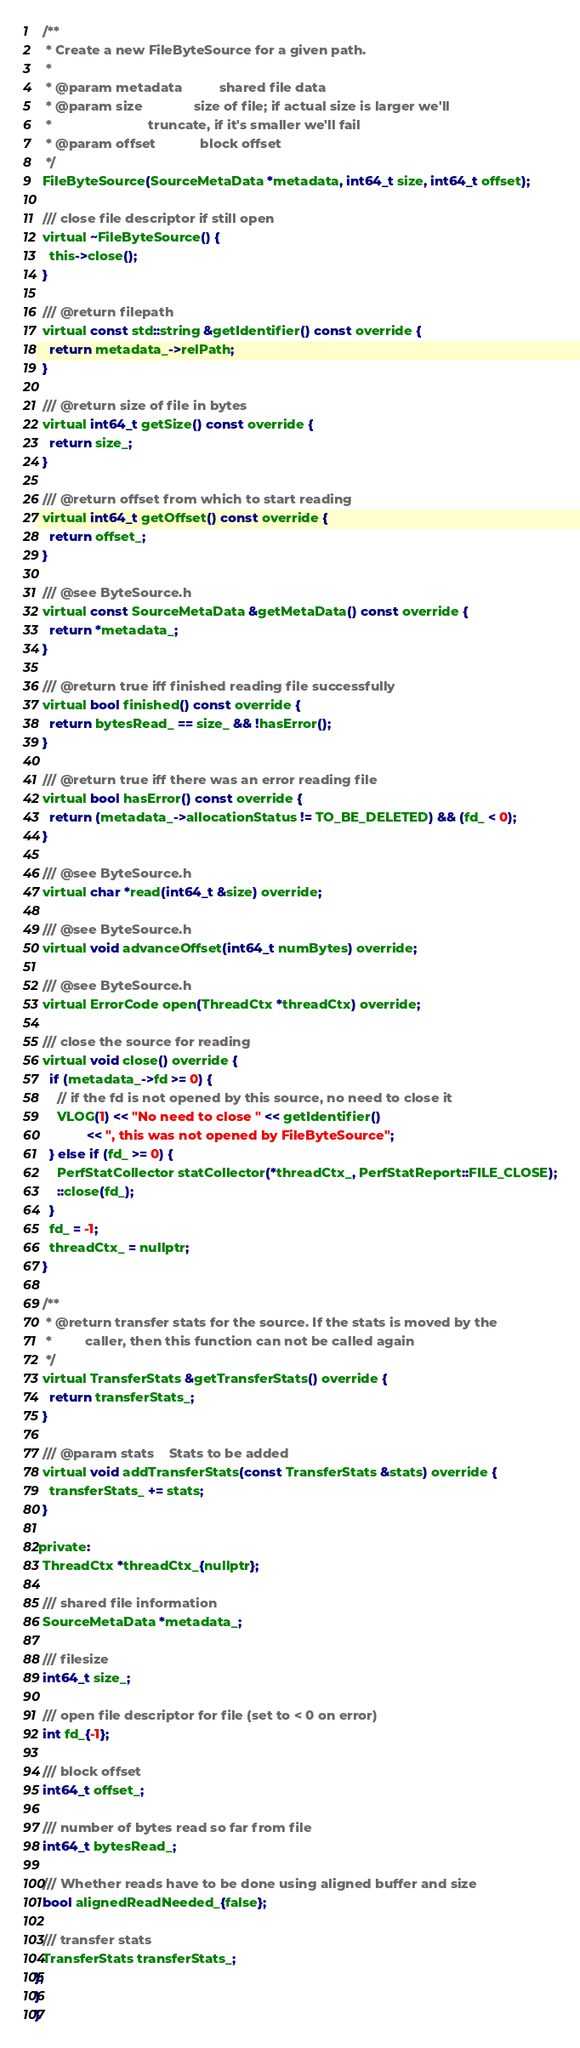<code> <loc_0><loc_0><loc_500><loc_500><_C_>  /**
   * Create a new FileByteSource for a given path.
   *
   * @param metadata          shared file data
   * @param size              size of file; if actual size is larger we'll
   *                          truncate, if it's smaller we'll fail
   * @param offset            block offset
   */
  FileByteSource(SourceMetaData *metadata, int64_t size, int64_t offset);

  /// close file descriptor if still open
  virtual ~FileByteSource() {
    this->close();
  }

  /// @return filepath
  virtual const std::string &getIdentifier() const override {
    return metadata_->relPath;
  }

  /// @return size of file in bytes
  virtual int64_t getSize() const override {
    return size_;
  }

  /// @return offset from which to start reading
  virtual int64_t getOffset() const override {
    return offset_;
  }

  /// @see ByteSource.h
  virtual const SourceMetaData &getMetaData() const override {
    return *metadata_;
  }

  /// @return true iff finished reading file successfully
  virtual bool finished() const override {
    return bytesRead_ == size_ && !hasError();
  }

  /// @return true iff there was an error reading file
  virtual bool hasError() const override {
    return (metadata_->allocationStatus != TO_BE_DELETED) && (fd_ < 0);
  }

  /// @see ByteSource.h
  virtual char *read(int64_t &size) override;

  /// @see ByteSource.h
  virtual void advanceOffset(int64_t numBytes) override;

  /// @see ByteSource.h
  virtual ErrorCode open(ThreadCtx *threadCtx) override;

  /// close the source for reading
  virtual void close() override {
    if (metadata_->fd >= 0) {
      // if the fd is not opened by this source, no need to close it
      VLOG(1) << "No need to close " << getIdentifier()
              << ", this was not opened by FileByteSource";
    } else if (fd_ >= 0) {
      PerfStatCollector statCollector(*threadCtx_, PerfStatReport::FILE_CLOSE);
      ::close(fd_);
    }
    fd_ = -1;
    threadCtx_ = nullptr;
  }

  /**
   * @return transfer stats for the source. If the stats is moved by the
   *         caller, then this function can not be called again
   */
  virtual TransferStats &getTransferStats() override {
    return transferStats_;
  }

  /// @param stats    Stats to be added
  virtual void addTransferStats(const TransferStats &stats) override {
    transferStats_ += stats;
  }

 private:
  ThreadCtx *threadCtx_{nullptr};

  /// shared file information
  SourceMetaData *metadata_;

  /// filesize
  int64_t size_;

  /// open file descriptor for file (set to < 0 on error)
  int fd_{-1};

  /// block offset
  int64_t offset_;

  /// number of bytes read so far from file
  int64_t bytesRead_;

  /// Whether reads have to be done using aligned buffer and size
  bool alignedReadNeeded_{false};

  /// transfer stats
  TransferStats transferStats_;
};
}
}
</code> 